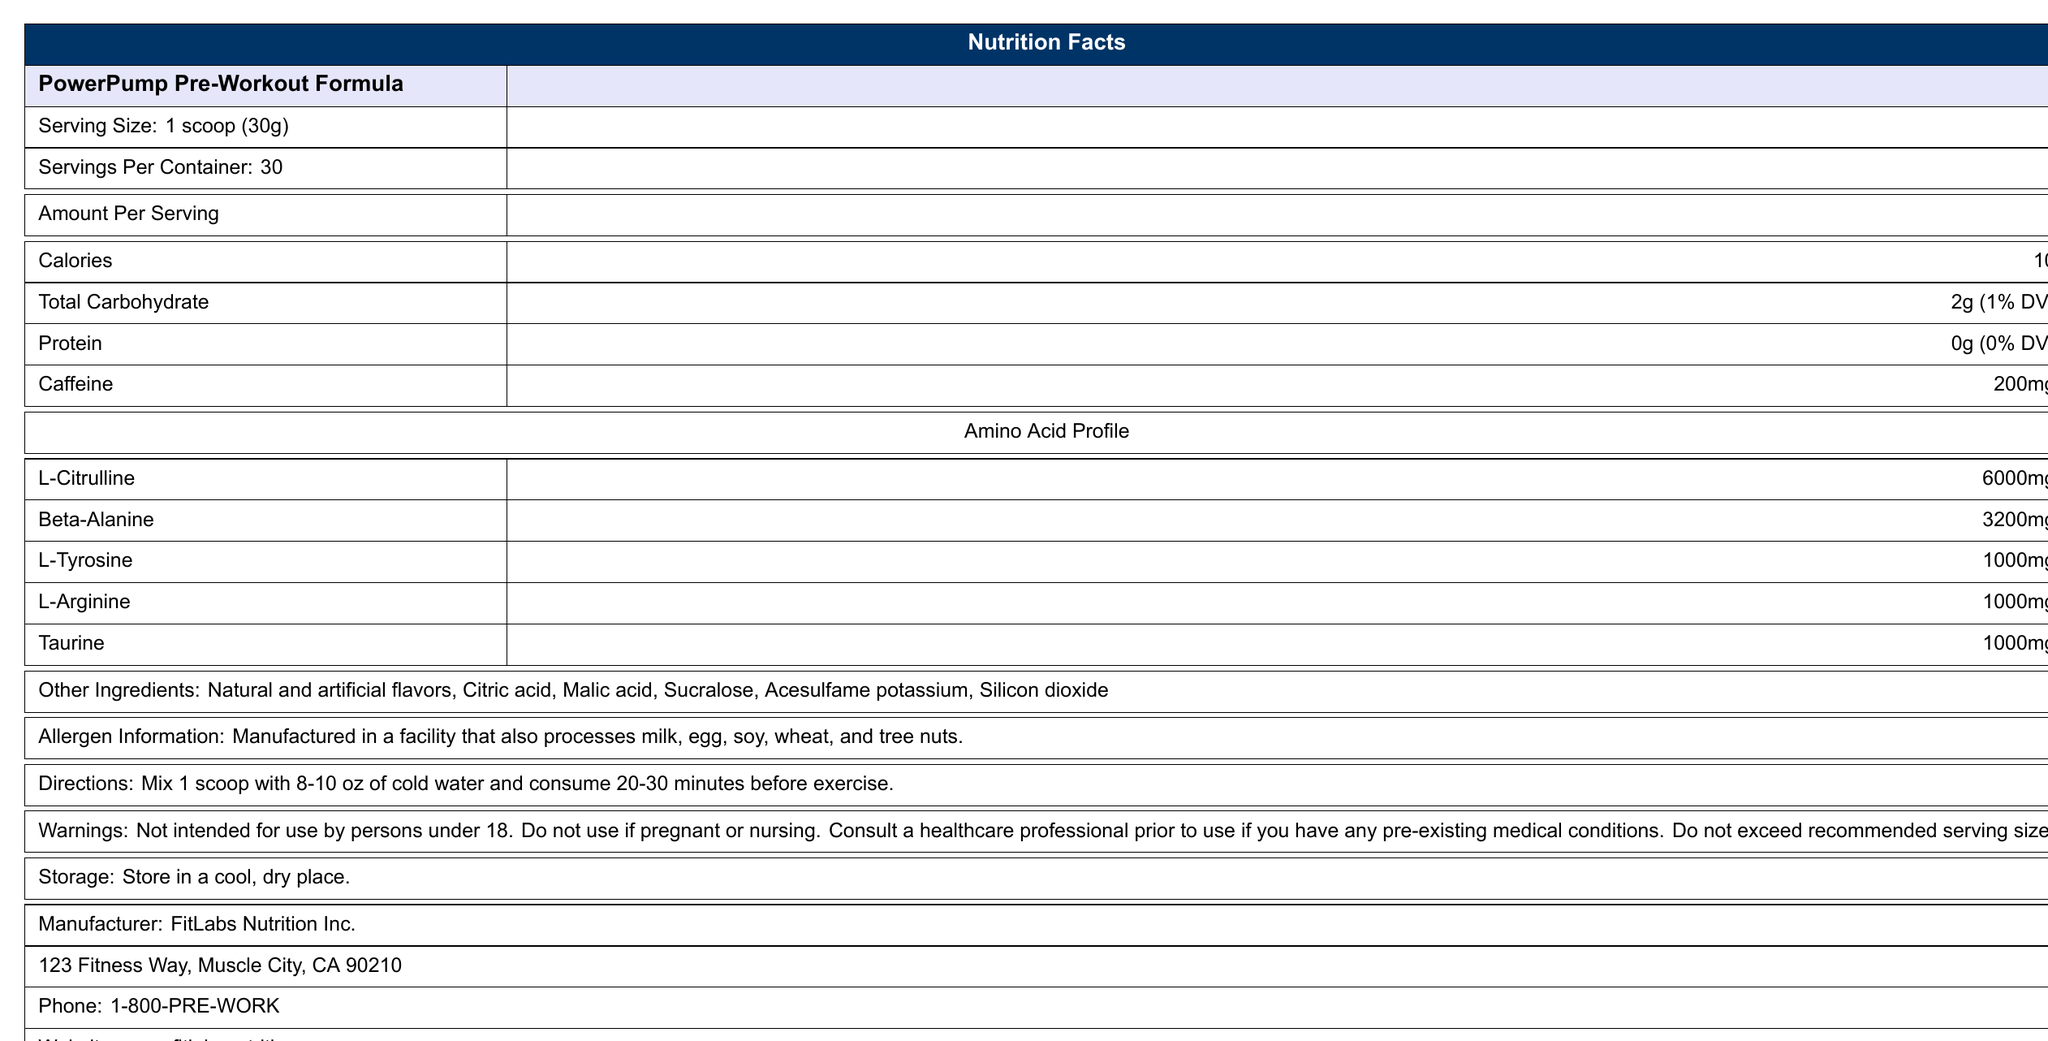what is the serving size of PowerPump Pre-Workout Formula? The document specifies the serving size as “1 scoop (30g)”.
Answer: 1 scoop (30g) how much caffeine is present per serving? The document clearly mentions that each serving contains 200mg of caffeine.
Answer: 200mg what is the amount of L-Citrulline per serving? The Amino Acid Profile section lists L-Citrulline as 6000mg per serving.
Answer: 6000mg are there any allergens mentioned in the product? The Allergens Information section states that the product is manufactured in a facility that also processes milk, egg, soy, wheat, and tree nuts.
Answer: Yes what should one do if they are pregnant and want to use this product? The warnings section explicitly mentions not to use the product if pregnant or nursing.
Answer: Do not use where is the manufacturer located? The manufacturer information lists the address as 123 Fitness Way, Muscle City, CA 90210.
Answer: 123 Fitness Way, Muscle City, CA 90210 how many servings are contained in one container? The document indicates there are 30 servings per container.
Answer: 30 what are the instructions for consuming this pre-workout powder? The directions section provides the consumption instructions.
Answer: Mix 1 scoop with 8-10 oz of cold water and consume 20-30 minutes before exercise. which of the following amino acids is present in 3200mg per serving? A. L-Citrulline B. Beta-Alanine C. L-Tyrosine D. L-Arginine The amino acid profile shows that Beta-Alanine is present in 3200mg per serving.
Answer: B which of these ingredients is NOT listed as other ingredients in the product? 1. Citric acid 2. Malic acid 3. Silicon dioxide 4. Aspartame The document lists the other ingredients as natural and artificial flavors, citric acid, malic acid, sucralose, acesulfame potassium, and silicon dioxide. Aspartame is not mentioned.
Answer: 4 is this product intended for persons under 18? The warnings section specifies that it is not intended for use by persons under 18.
Answer: No provide a brief summary of PowerPump Pre-Workout Formula. The document provides details about the product’s nutritional content, directions for use, warnings, manufacturer information, and other relevant details.
Answer: PowerPump Pre-Workout Formula is a supplement designed for consumption before exercise. Each serving contains 10 calories, 2g of carbohydrates, and 200mg of caffeine. It features an amino acid profile that includes L-Citrulline, Beta-Alanine, L-Tyrosine, L-Arginine, and Taurine in varying amounts. The product is intended for adult use only and has specific preparation and consumption instructions. is there any information about the flavor of the product? The document mentions natural and artificial flavors as ingredients but does not specify the flavor of the product.
Answer: Not enough information what is the website for FitLabs Nutrition Inc.? The contact information section lists the website as www.fitlabsnutrition.com.
Answer: www.fitlabsnutrition.com how should the product be stored? The storage section specifies that the product should be stored in a cool, dry place.
Answer: Store in a cool, dry place. 